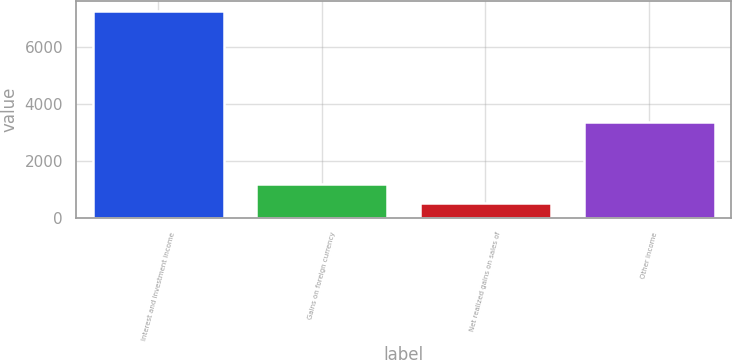Convert chart to OTSL. <chart><loc_0><loc_0><loc_500><loc_500><bar_chart><fcel>Interest and investment income<fcel>Gains on foreign currency<fcel>Net realized gains on sales of<fcel>Other income<nl><fcel>7232<fcel>1198.4<fcel>528<fcel>3374<nl></chart> 